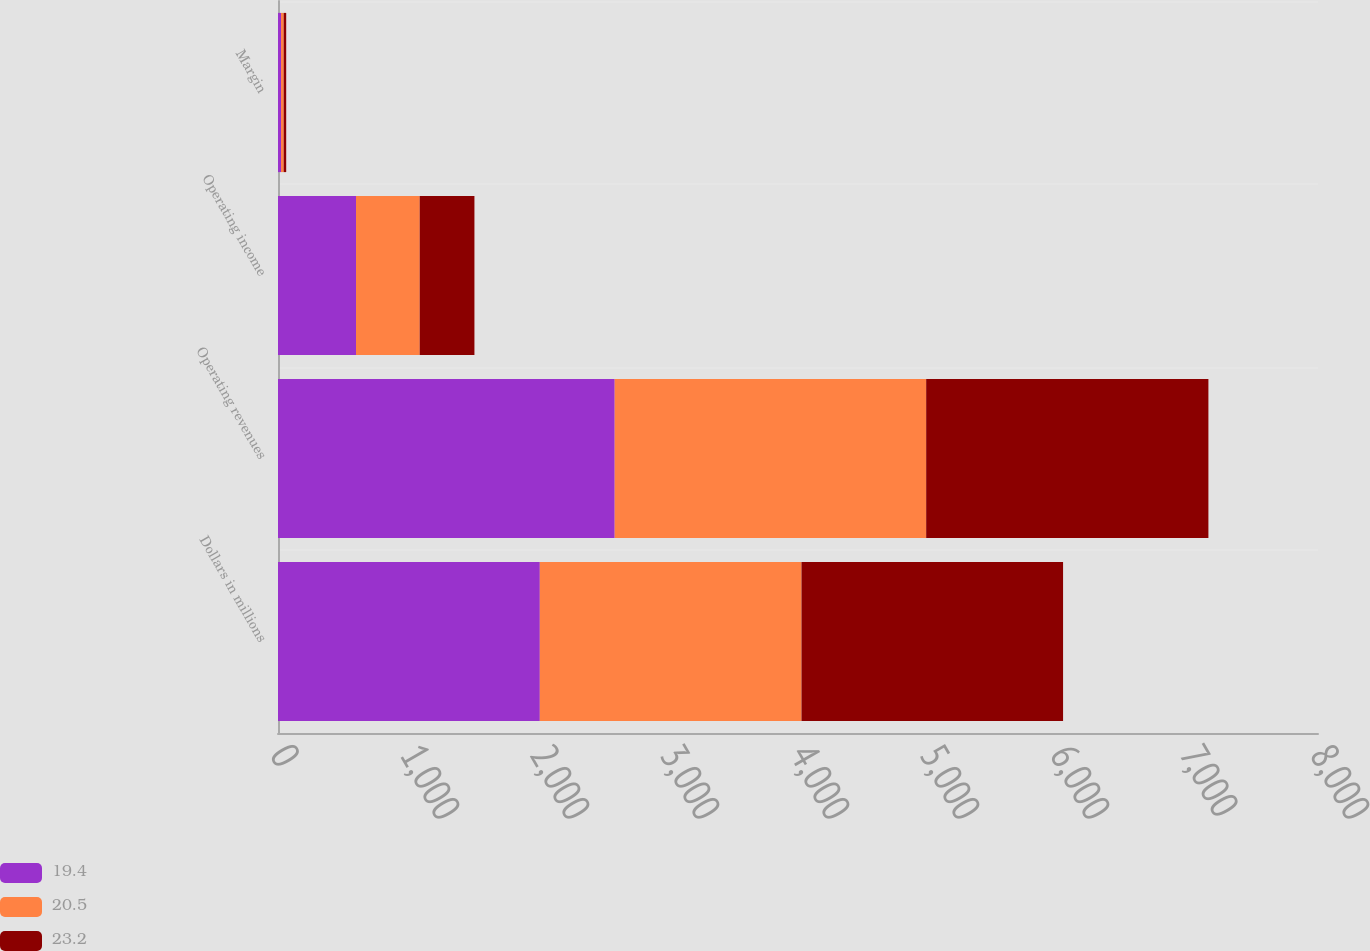<chart> <loc_0><loc_0><loc_500><loc_500><stacked_bar_chart><ecel><fcel>Dollars in millions<fcel>Operating revenues<fcel>Operating income<fcel>Margin<nl><fcel>19.4<fcel>2014<fcel>2590<fcel>600<fcel>23.2<nl><fcel>20.5<fcel>2013<fcel>2396<fcel>490<fcel>20.5<nl><fcel>23.2<fcel>2012<fcel>2171<fcel>421<fcel>19.4<nl></chart> 